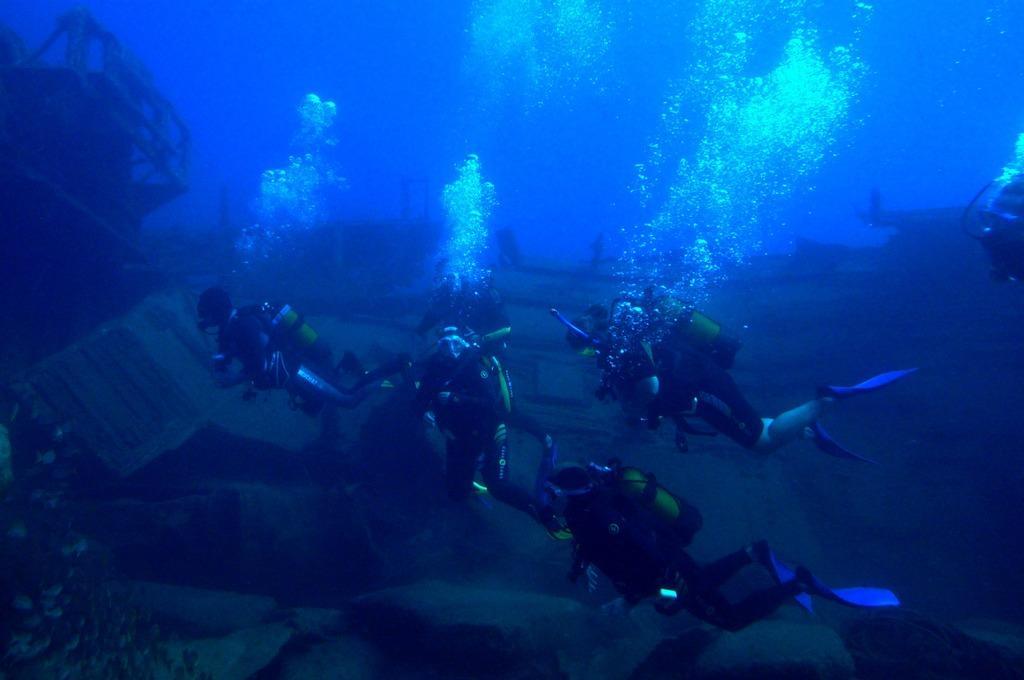Could you give a brief overview of what you see in this image? In this image, we can see some persons under water. 